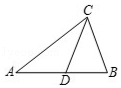In triangle ABC, given that CD is the midline, AB is 40 units long, what is the length of AD? In the diagram of triangle ABC, CD acts as the median, connecting midpoint D with vertex C. Since AB, the base of the triangle, measures 40 units, the line segment AD, being half of AB due to the properties of a median in a triangle, measures exactly 20 units. This allows us to understand the proportional relationships within the triangle, providing insight into its geometric structure. 